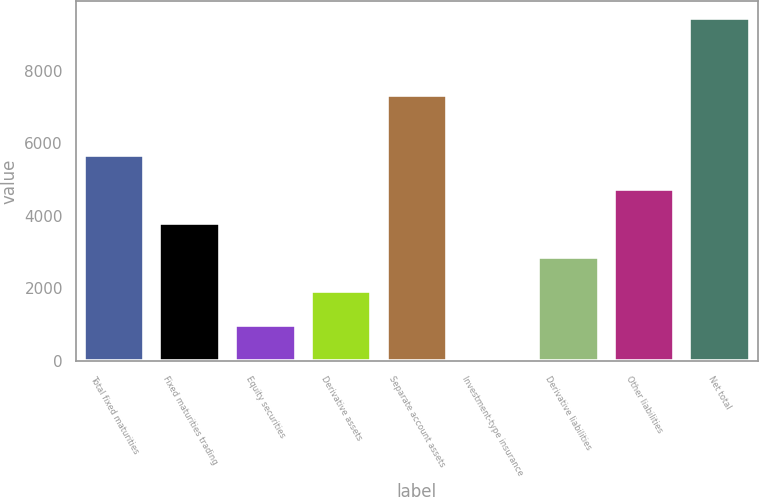Convert chart to OTSL. <chart><loc_0><loc_0><loc_500><loc_500><bar_chart><fcel>Total fixed maturities<fcel>Fixed maturities trading<fcel>Equity securities<fcel>Derivative assets<fcel>Separate account assets<fcel>Investment-type insurance<fcel>Derivative liabilities<fcel>Other liabilities<fcel>Net total<nl><fcel>5686.72<fcel>3807.58<fcel>988.87<fcel>1928.44<fcel>7313.2<fcel>49.3<fcel>2868.01<fcel>4747.15<fcel>9445<nl></chart> 